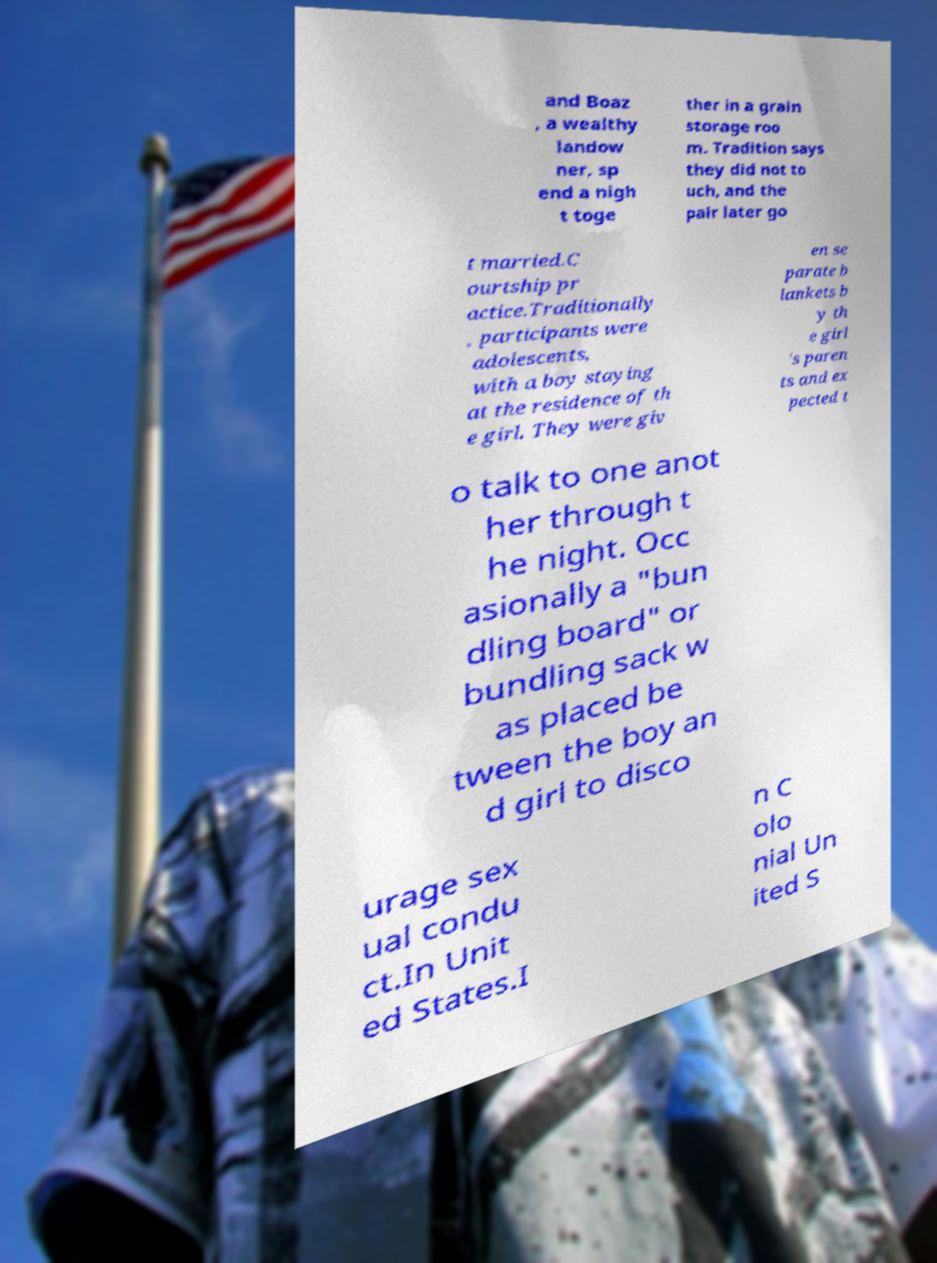Could you assist in decoding the text presented in this image and type it out clearly? and Boaz , a wealthy landow ner, sp end a nigh t toge ther in a grain storage roo m. Tradition says they did not to uch, and the pair later go t married.C ourtship pr actice.Traditionally , participants were adolescents, with a boy staying at the residence of th e girl. They were giv en se parate b lankets b y th e girl 's paren ts and ex pected t o talk to one anot her through t he night. Occ asionally a "bun dling board" or bundling sack w as placed be tween the boy an d girl to disco urage sex ual condu ct.In Unit ed States.I n C olo nial Un ited S 